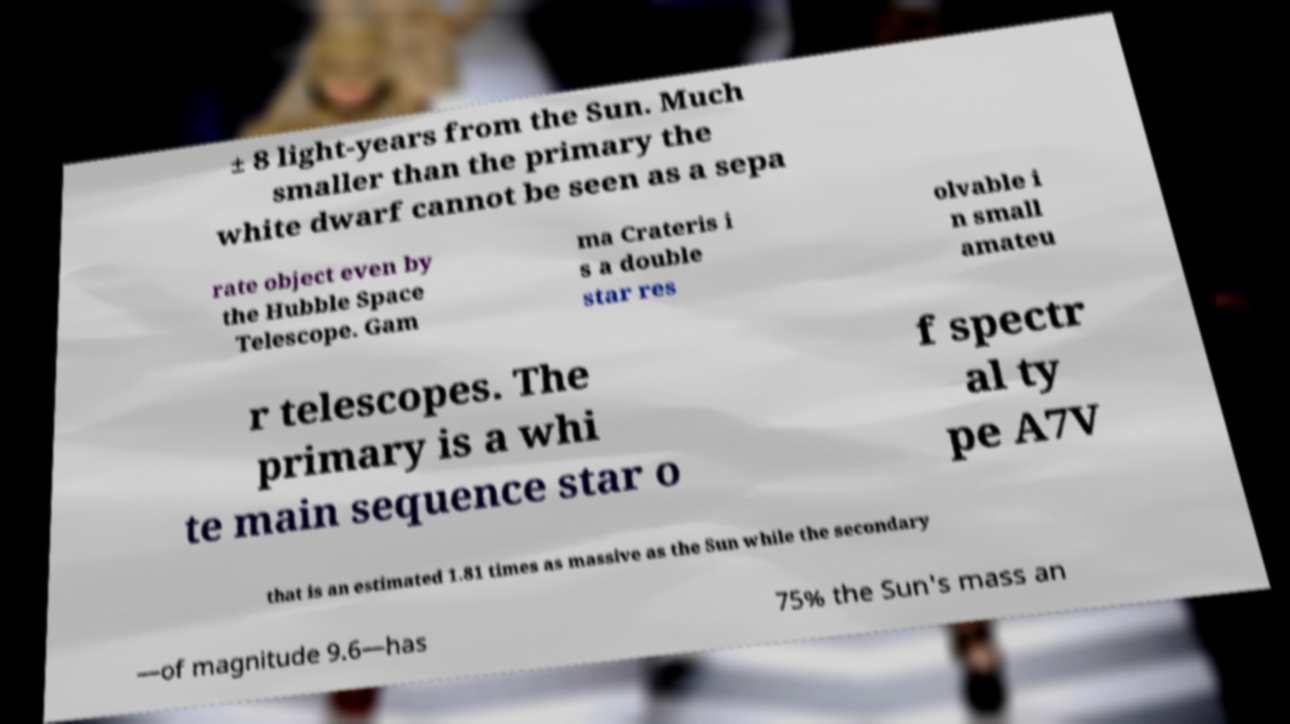Can you read and provide the text displayed in the image?This photo seems to have some interesting text. Can you extract and type it out for me? ± 8 light-years from the Sun. Much smaller than the primary the white dwarf cannot be seen as a sepa rate object even by the Hubble Space Telescope. Gam ma Crateris i s a double star res olvable i n small amateu r telescopes. The primary is a whi te main sequence star o f spectr al ty pe A7V that is an estimated 1.81 times as massive as the Sun while the secondary —of magnitude 9.6—has 75% the Sun's mass an 